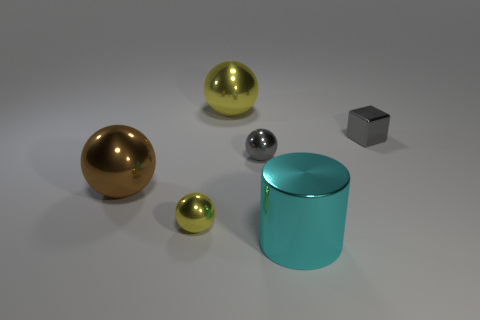How many shiny balls have the same color as the tiny shiny block?
Ensure brevity in your answer.  1. The thing that is the same color as the small cube is what size?
Offer a very short reply. Small. Does the yellow thing that is in front of the large brown thing have the same shape as the cyan shiny thing?
Give a very brief answer. No. The small metal object that is on the right side of the tiny metallic ball on the right side of the yellow object behind the tiny cube is what shape?
Keep it short and to the point. Cube. There is a large thing behind the brown sphere; what is it made of?
Provide a short and direct response. Metal. There is a metallic cylinder that is the same size as the brown metal object; what color is it?
Provide a succinct answer. Cyan. What number of other things are there of the same shape as the brown object?
Provide a succinct answer. 3. Do the cylinder and the gray shiny ball have the same size?
Keep it short and to the point. No. Is the number of small metal things that are right of the large cyan metallic thing greater than the number of big metal cylinders on the left side of the brown metal sphere?
Offer a very short reply. Yes. What number of other objects are the same size as the brown thing?
Ensure brevity in your answer.  2. 